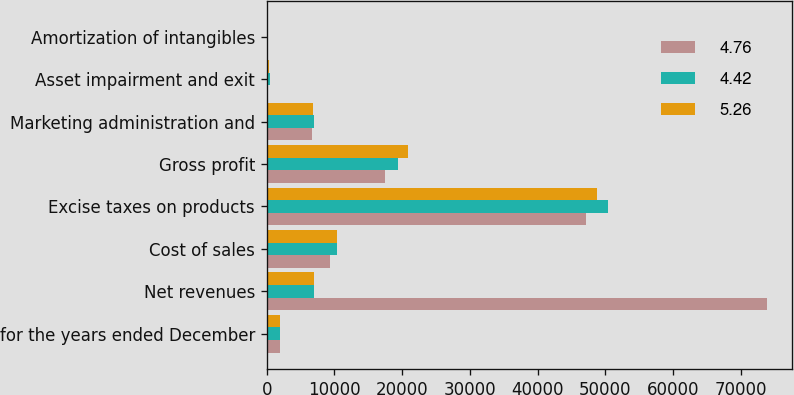<chart> <loc_0><loc_0><loc_500><loc_500><stacked_bar_chart><ecel><fcel>for the years ended December<fcel>Net revenues<fcel>Cost of sales<fcel>Excise taxes on products<fcel>Gross profit<fcel>Marketing administration and<fcel>Asset impairment and exit<fcel>Amortization of intangibles<nl><fcel>4.76<fcel>2015<fcel>73908<fcel>9365<fcel>47114<fcel>17429<fcel>6656<fcel>68<fcel>82<nl><fcel>4.42<fcel>2014<fcel>6945.5<fcel>10436<fcel>50339<fcel>19331<fcel>7001<fcel>535<fcel>93<nl><fcel>5.26<fcel>2013<fcel>6945.5<fcel>10410<fcel>48812<fcel>20807<fcel>6890<fcel>309<fcel>93<nl></chart> 